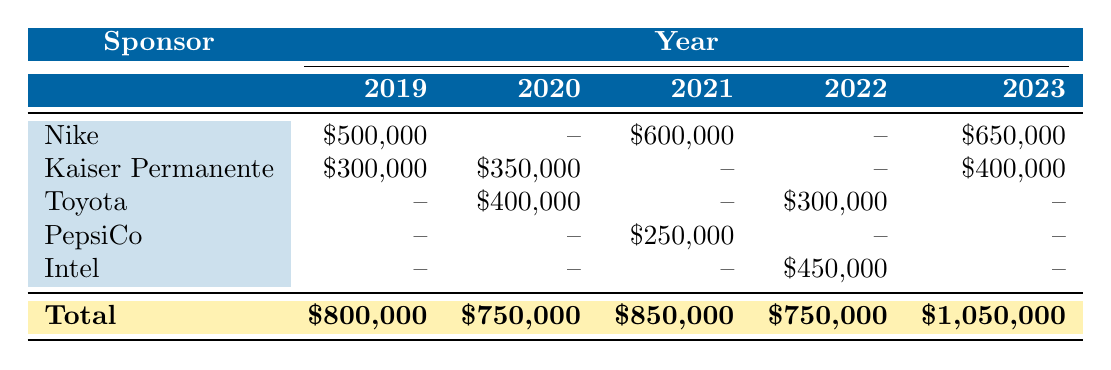What was the sponsorship revenue from Nike in 2021? In the row for Nike and the column for 2021, the value is $600,000.
Answer: $600,000 Which corporate sponsor had the highest total sponsorship revenue across all years? Adding Nike's revenue ($500,000 + $600,000 + $650,000), Kaiser Permanente's revenue ($300,000 + $350,000 + $400,000), Toyota's revenue ($400,000 + $300,000), PepsiCo's revenue ($250,000), and Intel's revenue ($450,000) shows that Nike has a total of $1,750,000, which is higher than any other sponsor.
Answer: Nike Did Kaiser Permanente sponsor UC Irvine athletics in 2021? In the year 2021, Kaiser Permanente has no recorded sponsorship revenue. Therefore, the answer is no.
Answer: No What is the total sponsorship revenue for UC Irvine athletics in 2022? Summing the sponsorship revenues for 2022 (Intel: $450,000 + Toyota: $300,000) equals $750,000.
Answer: $750,000 Is the sponsorship revenue from Toyota consistent across the years it sponsored? Looking at Toyota's revenue across the years, it shows values of $400,000 in 2020, $300,000 in 2022, and no revenue in 2019 and 2021, indicating inconsistency.
Answer: No What was the average sponsorship revenue for UC Irvine athletics across all years? The total sponsorship revenue is $800,000 (2019) + $750,000 (2020) + $850,000 (2021) + $750,000 (2022) + $1,050,000 (2023) = $4,200,000. There are 5 years, so the average is $4,200,000 / 5 = $840,000.
Answer: $840,000 Which year had the lowest total sponsorship revenue? Comparing the totals for each year, the figures are $800,000 (2019), $750,000 (2020), $850,000 (2021), $750,000 (2022), and $1,050,000 (2023). The year 2020 and 2022 both had the lowest at $750,000.
Answer: 2020 and 2022 How much more sponsorship revenue did Nike contribute than Toyota in 2023? In 2023, Nike contributed $650,000 and Toyota contributed no revenue. The difference is $650,000 - $0 = $650,000.
Answer: $650,000 Did PepsiCo ever contribute more than $300,000 in sponsorship revenue across all years? PepsiCo contributed only $250,000 in 2021 and had no revenue in other years, so it did not contribute more than $300,000.
Answer: No 